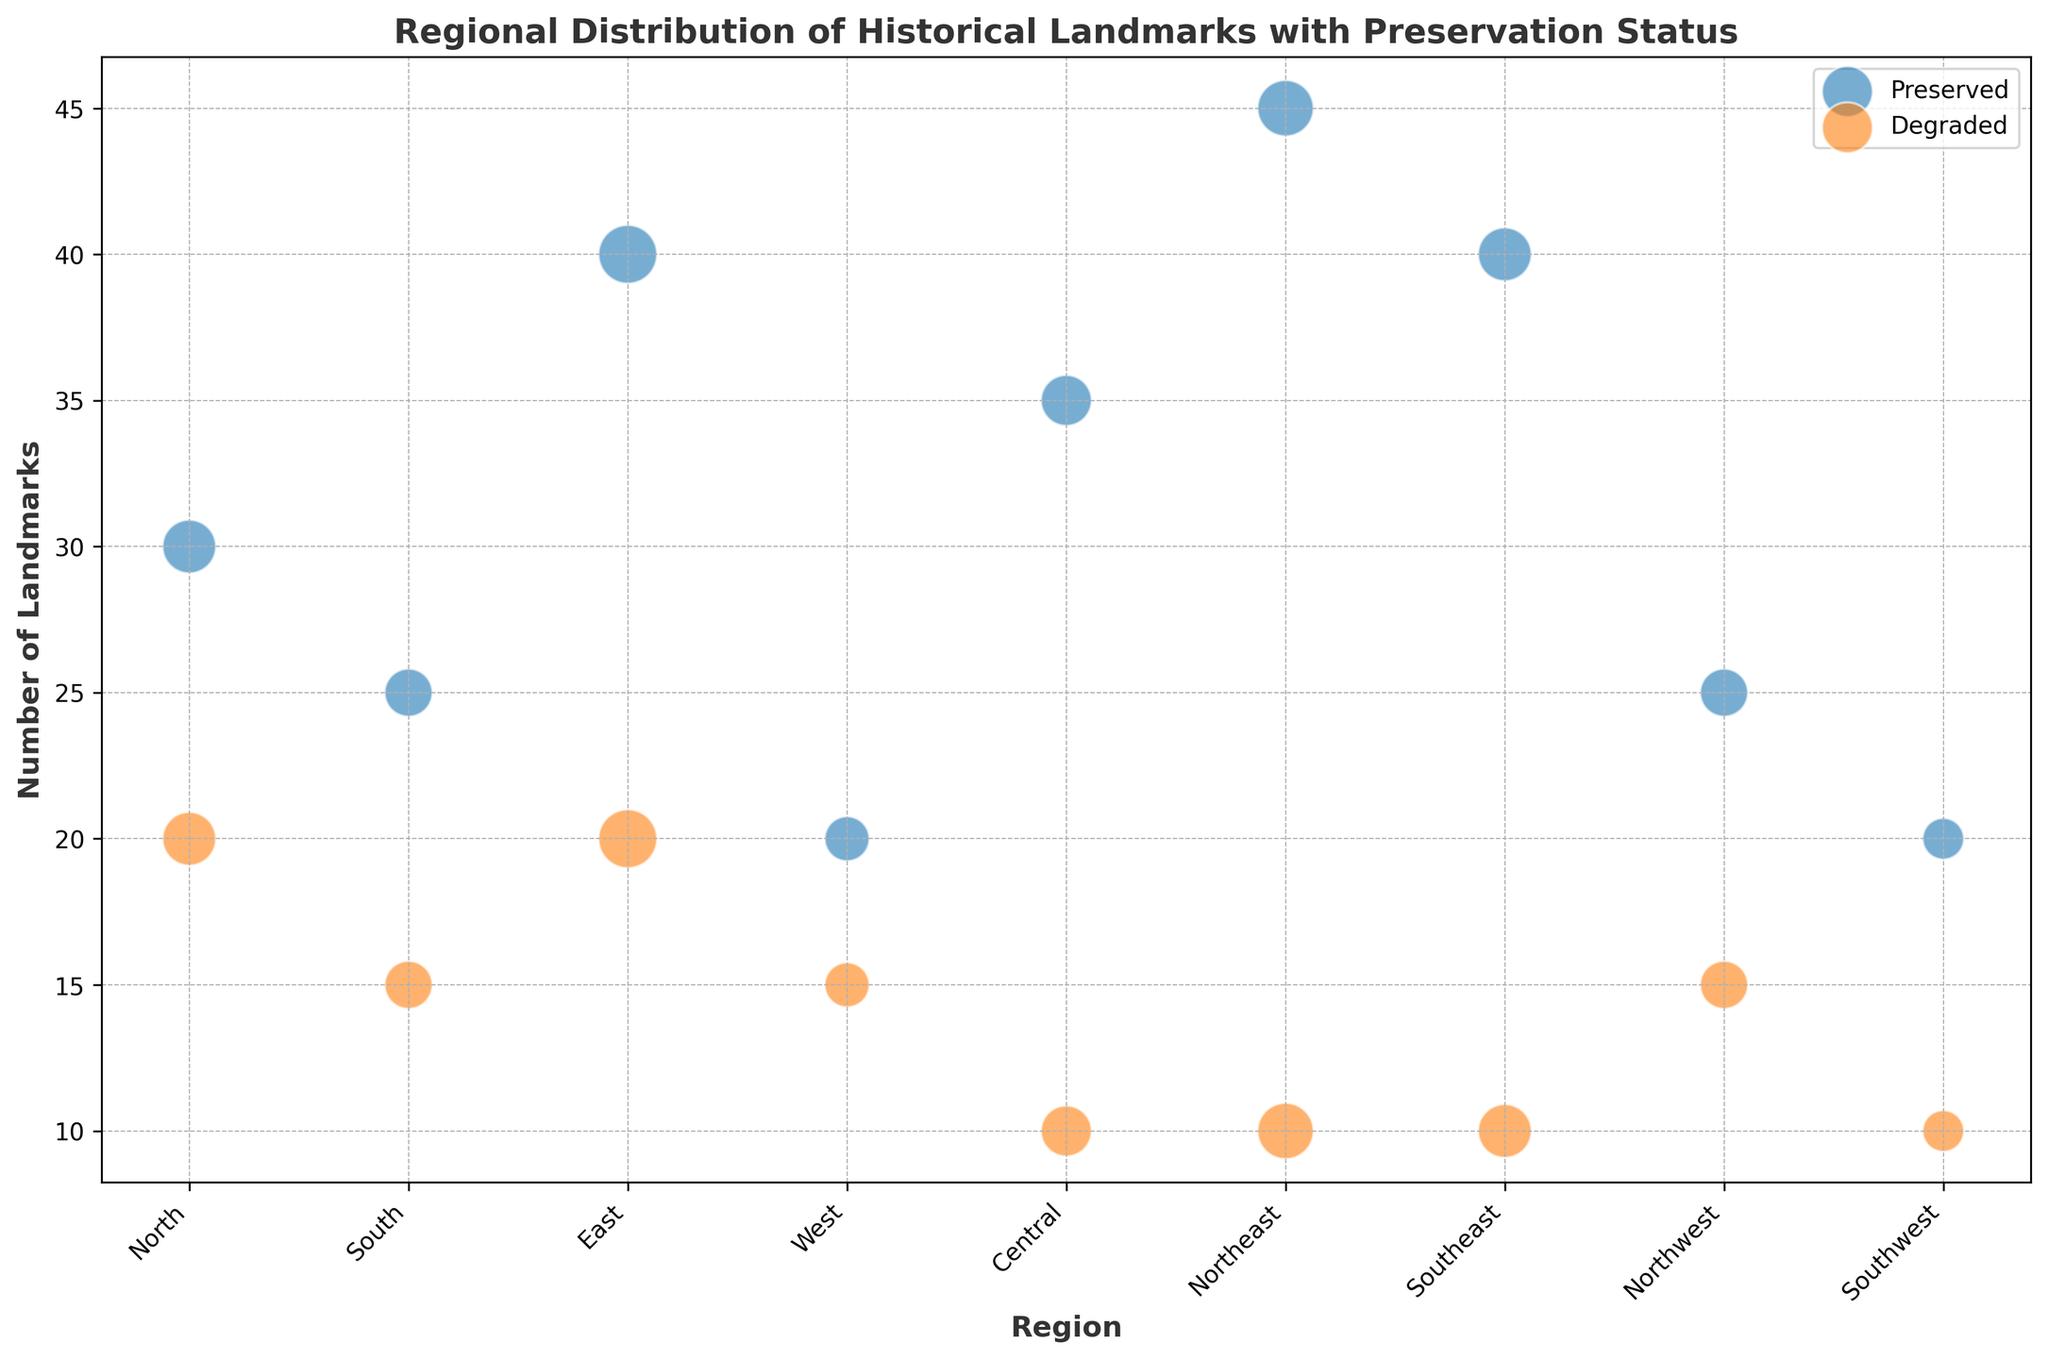Which region has the highest number of preserved landmarks? The figure shows bubble sizes and colors representing preserved (blue) and degraded (orange) landmarks for each region. By comparing the heights of the blue bubbles, the Northeast region has the highest number of preserved landmarks.
Answer: Northeast Which region has an equal number of preserved and degraded landmarks? By comparing the heights of the blue and orange bubbles, none of the regions have equal heights for preserved and degraded landmarks.
Answer: None What is the total number of landmarks in the South region? In the South region, the blue bubble represents 25 preserved landmarks, and the orange bubble represents 15 degraded landmarks. Summing these gives a total of 40 landmarks.
Answer: 40 Which region has the smallest number of degraded landmarks? By comparing the heights of the orange bubbles, the Northeast, Southeast, and Southwest regions show the smallest number (each with 10 degraded landmarks).
Answer: Northeast, Southeast, Southwest How many more preserved landmarks does the Northeast region have compared to the West region? The blue bubble in the Northeast represents 45 preserved landmarks, while the West has 20 preserved landmarks. Subtracting gives 45 - 20 = 25 more preserved landmarks in the Northeast region.
Answer: 25 Which region shows the highest proportion of preserved landmarks relative to their total landmarks? Calculate the proportion for each region and compare. For example, the Central region has 35 preserved out of 45 total, giving a proportion of 35/45 = 0.777 or 77.7%. By similar calculations for all regions, the best ratio is for the Northeast at 45 preserved out of 55 total (45/55 = 0.818 or ~81.8%).
Answer: Northeast Which region has the smallest number of total landmarks? By observing the bubble sizes, the Southwest region has the smallest bubble size, indicating it has the smallest total number of landmarks.
Answer: Southwest For the North region, what percentage of landmarks are preserved? The North region has 30 preserved out of 50 total landmarks. The percentage is calculated as (30/50) * 100 = 60%.
Answer: 60% Which region has more landmarks: Southeast or Northwest? The figure's bubble sizes show that the Southeast region has a larger bubble than the Northwest region. The Southeast has 50 landmarks, while the Northwest has 40 landmarks.
Answer: Southeast If we combine the regions East and West, what is the total number of preserved landmarks? The East region has 40 preserved landmarks, and the West region has 20 preserved landmarks. Adding these together gives a total of 60 preserved landmarks.
Answer: 60 